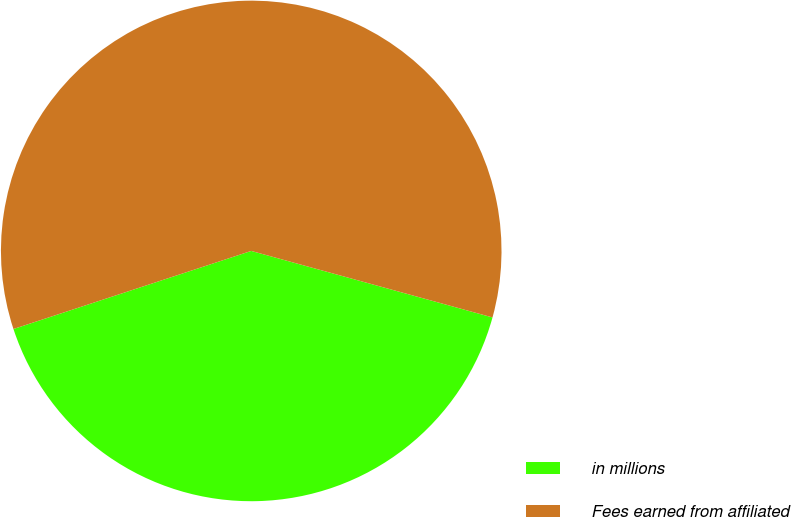<chart> <loc_0><loc_0><loc_500><loc_500><pie_chart><fcel>in millions<fcel>Fees earned from affiliated<nl><fcel>40.67%<fcel>59.33%<nl></chart> 